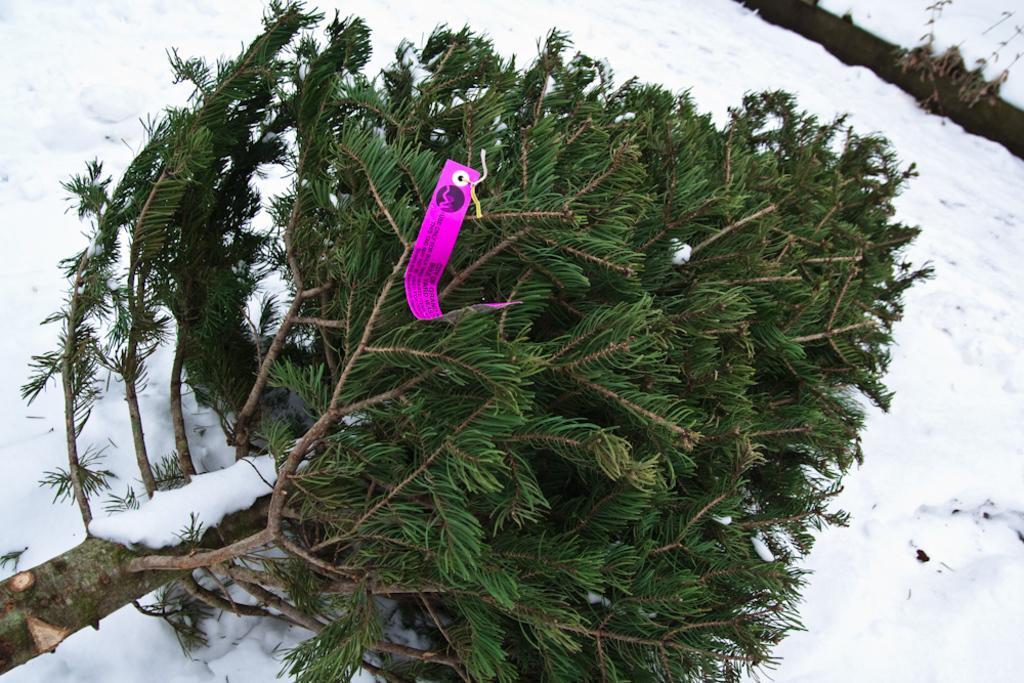Could you give a brief overview of what you see in this image? Here we can see a tree fallen on the snow and there is a tag on the tree and on the right at the top corner there is a log on the snow. 